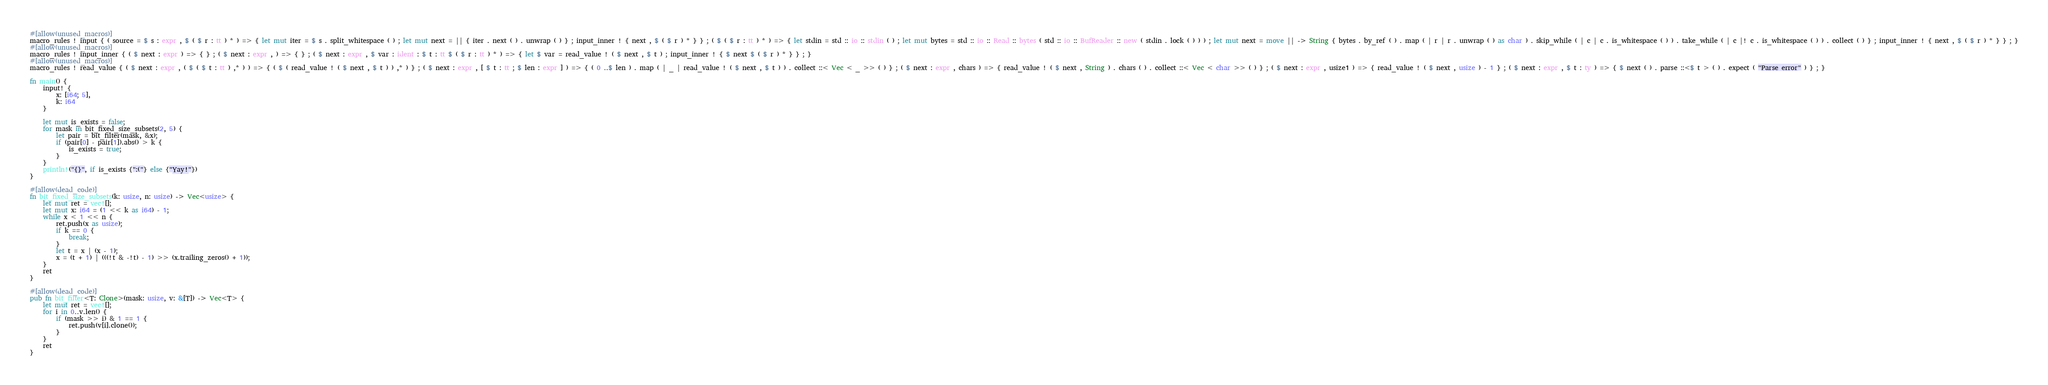<code> <loc_0><loc_0><loc_500><loc_500><_Rust_>#[allow(unused_macros)]
macro_rules ! input { ( source = $ s : expr , $ ( $ r : tt ) * ) => { let mut iter = $ s . split_whitespace ( ) ; let mut next = || { iter . next ( ) . unwrap ( ) } ; input_inner ! { next , $ ( $ r ) * } } ; ( $ ( $ r : tt ) * ) => { let stdin = std :: io :: stdin ( ) ; let mut bytes = std :: io :: Read :: bytes ( std :: io :: BufReader :: new ( stdin . lock ( ) ) ) ; let mut next = move || -> String { bytes . by_ref ( ) . map ( | r | r . unwrap ( ) as char ) . skip_while ( | c | c . is_whitespace ( ) ) . take_while ( | c |! c . is_whitespace ( ) ) . collect ( ) } ; input_inner ! { next , $ ( $ r ) * } } ; }
#[allow(unused_macros)]
macro_rules ! input_inner { ( $ next : expr ) => { } ; ( $ next : expr , ) => { } ; ( $ next : expr , $ var : ident : $ t : tt $ ( $ r : tt ) * ) => { let $ var = read_value ! ( $ next , $ t ) ; input_inner ! { $ next $ ( $ r ) * } } ; }
#[allow(unused_macros)]
macro_rules ! read_value { ( $ next : expr , ( $ ( $ t : tt ) ,* ) ) => { ( $ ( read_value ! ( $ next , $ t ) ) ,* ) } ; ( $ next : expr , [ $ t : tt ; $ len : expr ] ) => { ( 0 ..$ len ) . map ( | _ | read_value ! ( $ next , $ t ) ) . collect ::< Vec < _ >> ( ) } ; ( $ next : expr , chars ) => { read_value ! ( $ next , String ) . chars ( ) . collect ::< Vec < char >> ( ) } ; ( $ next : expr , usize1 ) => { read_value ! ( $ next , usize ) - 1 } ; ( $ next : expr , $ t : ty ) => { $ next ( ) . parse ::<$ t > ( ) . expect ( "Parse error" ) } ; }

fn main() {
    input! {
        x: [i64; 5],
        k: i64
    }

    let mut is_exists = false;
    for mask in bit_fixed_size_subsets(2, 5) {
        let pair = bit_filter(mask, &x);
        if (pair[0] - pair[1]).abs() > k {
            is_exists = true;
        }
    }
    println!("{}", if is_exists {":("} else {"Yay!"})
}

#[allow(dead_code)]
fn bit_fixed_size_subsets(k: usize, n: usize) -> Vec<usize> {
    let mut ret = vec![];
    let mut x: i64 = (1 << k as i64) - 1;
    while x < 1 << n {
        ret.push(x as usize);
        if k == 0 {
            break;
        }
        let t = x | (x - 1);
        x = (t + 1) | (((!t & -!t) - 1) >> (x.trailing_zeros() + 1));
    }
    ret
}

#[allow(dead_code)]
pub fn bit_filter<T: Clone>(mask: usize, v: &[T]) -> Vec<T> {
    let mut ret = vec![];
    for i in 0..v.len() {
        if (mask >> i) & 1 == 1 {
            ret.push(v[i].clone());
        }
    }
    ret
}</code> 